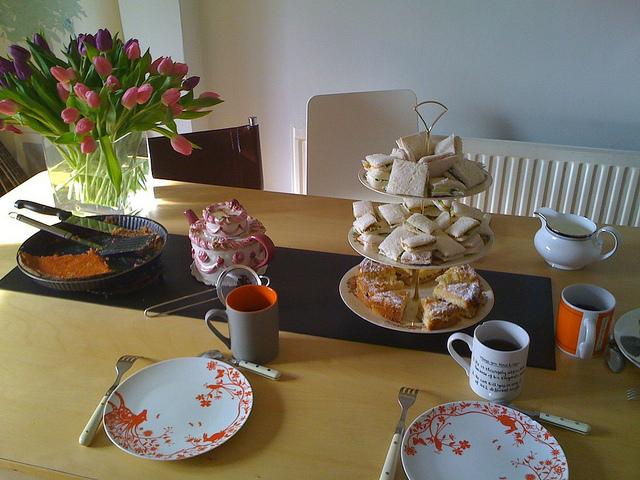Are the flowers artificial?
Short answer required. No. Has anyone ate any of the pie?
Answer briefly. Yes. What color is most represented here?
Answer briefly. White. How are the utensils on the left positioned?
Keep it brief. 2. How many cups on the table?
Quick response, please. 3. What is next to the flowers?
Short answer required. Plate. 